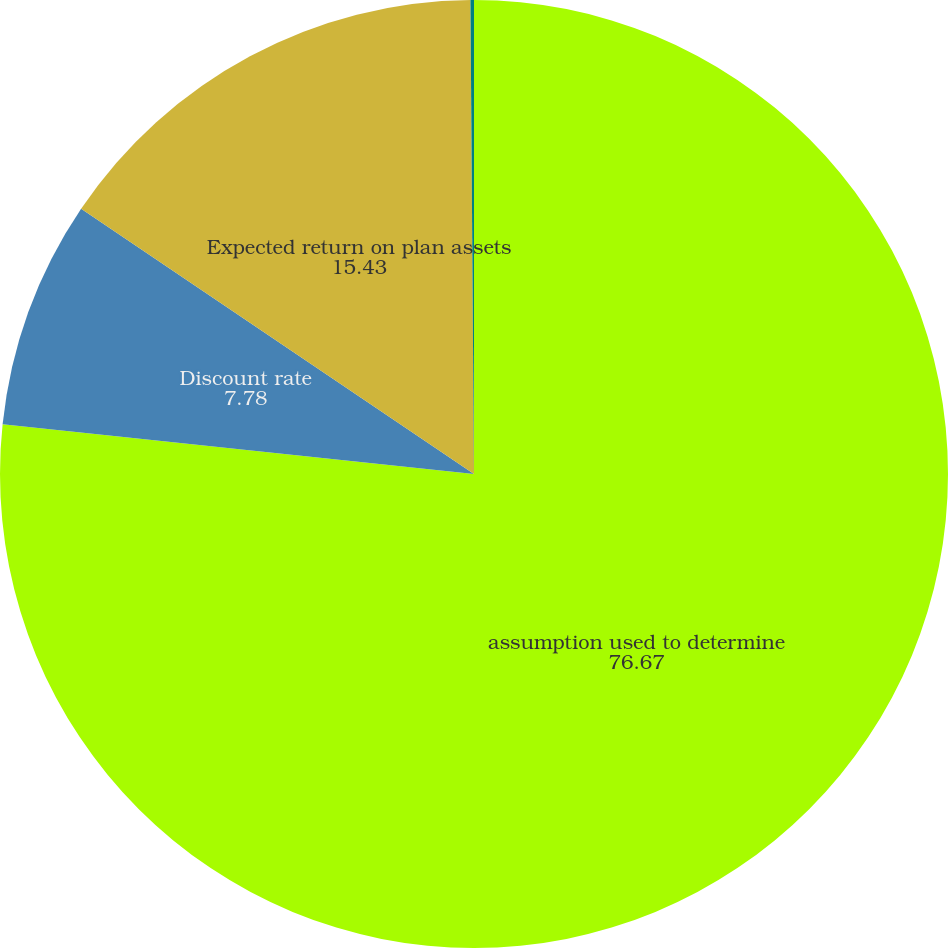Convert chart to OTSL. <chart><loc_0><loc_0><loc_500><loc_500><pie_chart><fcel>assumption used to determine<fcel>Discount rate<fcel>Expected return on plan assets<fcel>Rate of compensation increase<nl><fcel>76.67%<fcel>7.78%<fcel>15.43%<fcel>0.12%<nl></chart> 